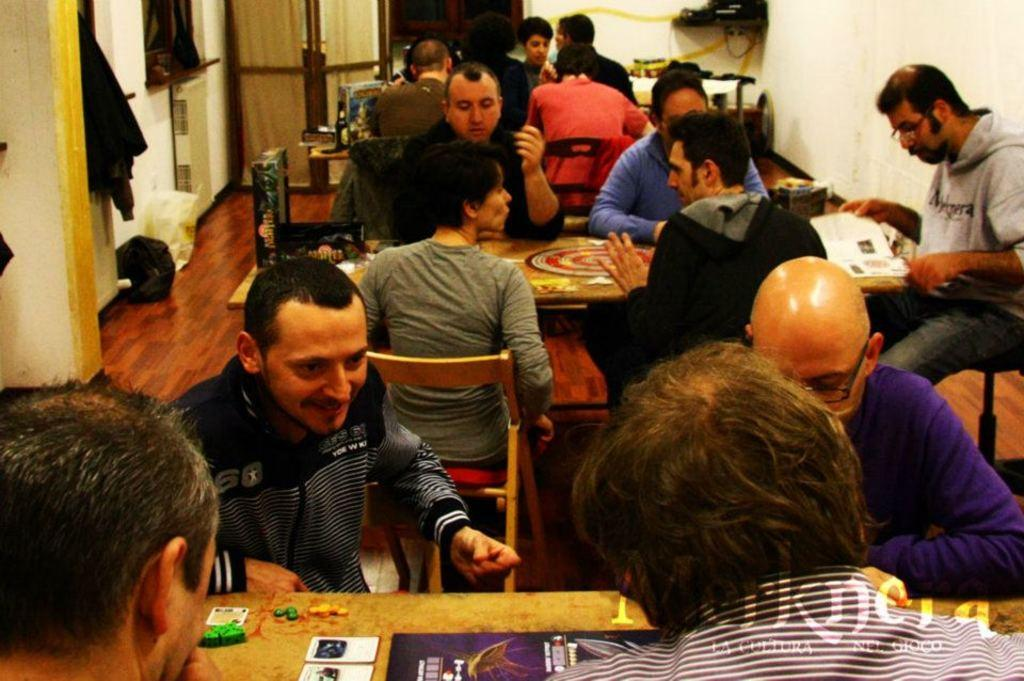How many people are in the image? There is a group of people in the image. What are the people doing in the image? The people are sitting in front of a table. What can be seen in the background of the image? There is a door, a wall, and clothes in the background of the image. What type of volleyball game is being played in the image? There is no volleyball game present in the image. How comfortable are the chairs the people are sitting on? The provided facts do not mention the comfort of the chairs, so it cannot be determined from the image. 